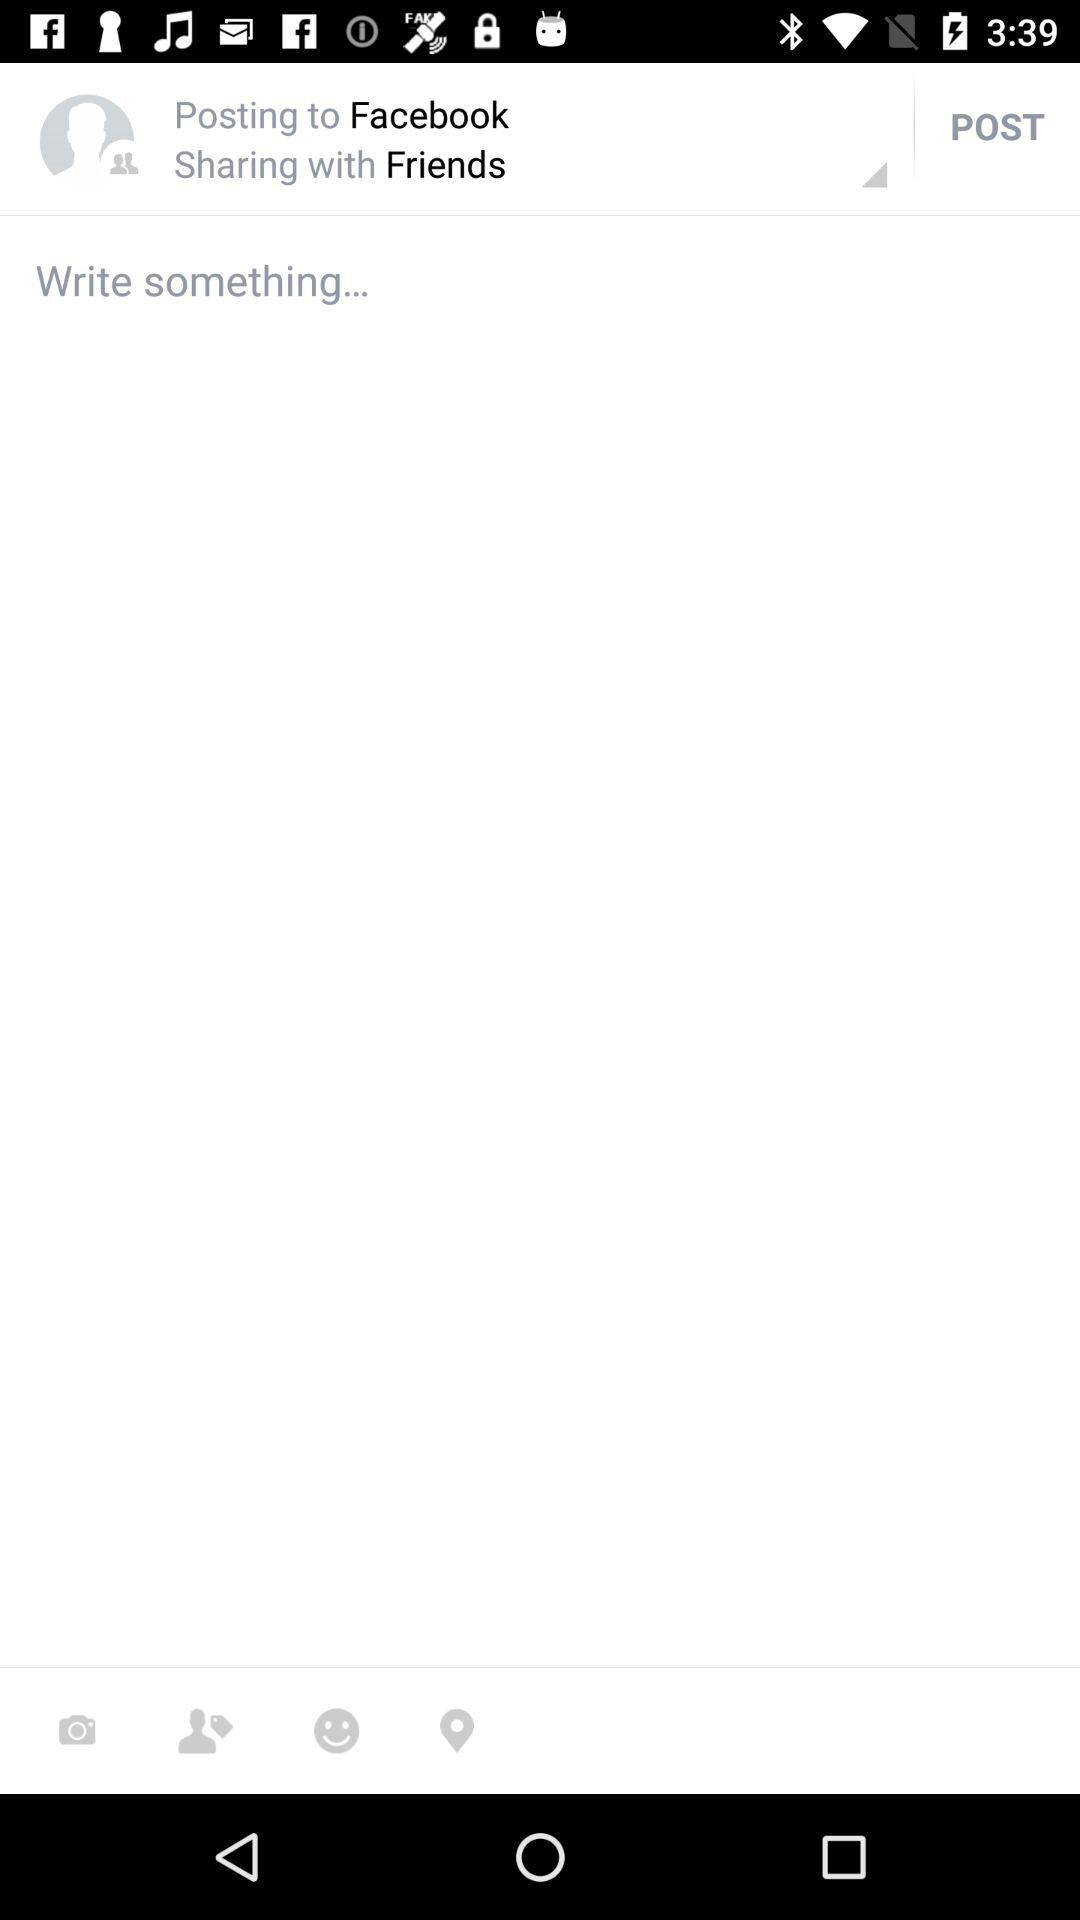To whom will my post be shared? Your post will be shared with friends. 